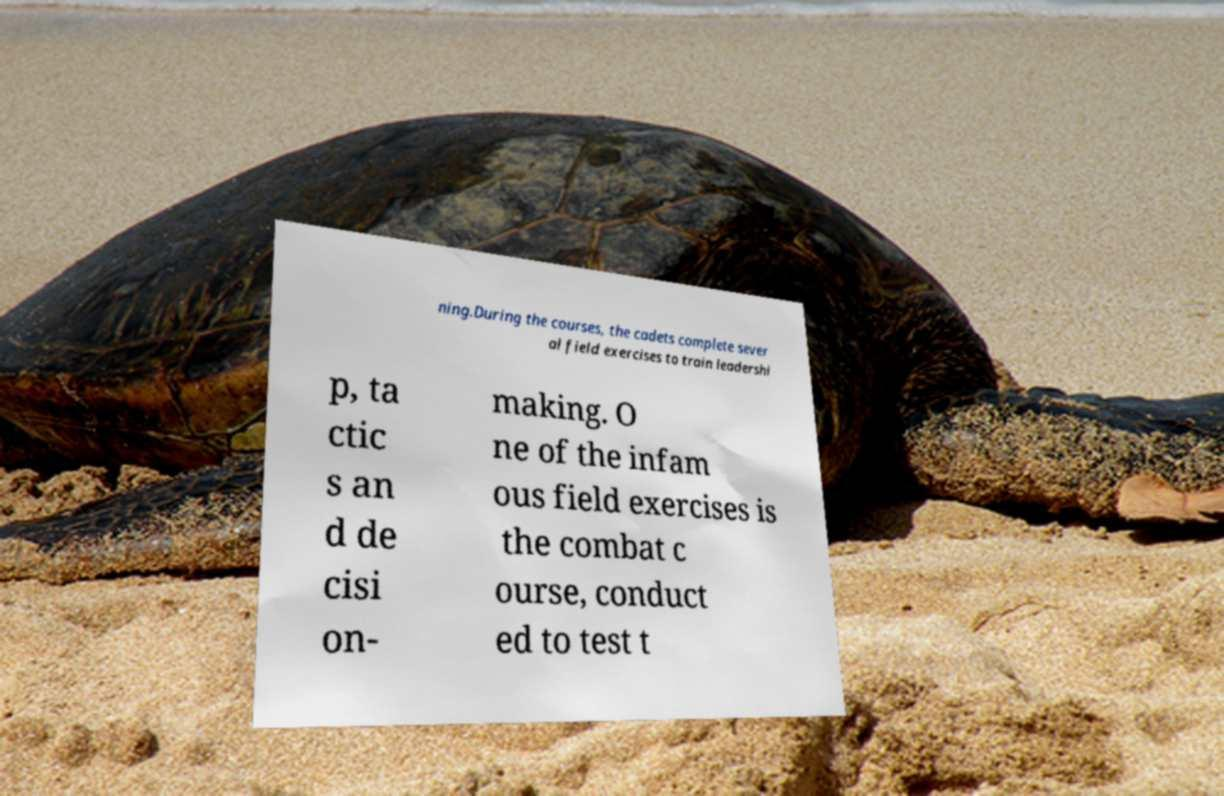For documentation purposes, I need the text within this image transcribed. Could you provide that? ning.During the courses, the cadets complete sever al field exercises to train leadershi p, ta ctic s an d de cisi on- making. O ne of the infam ous field exercises is the combat c ourse, conduct ed to test t 